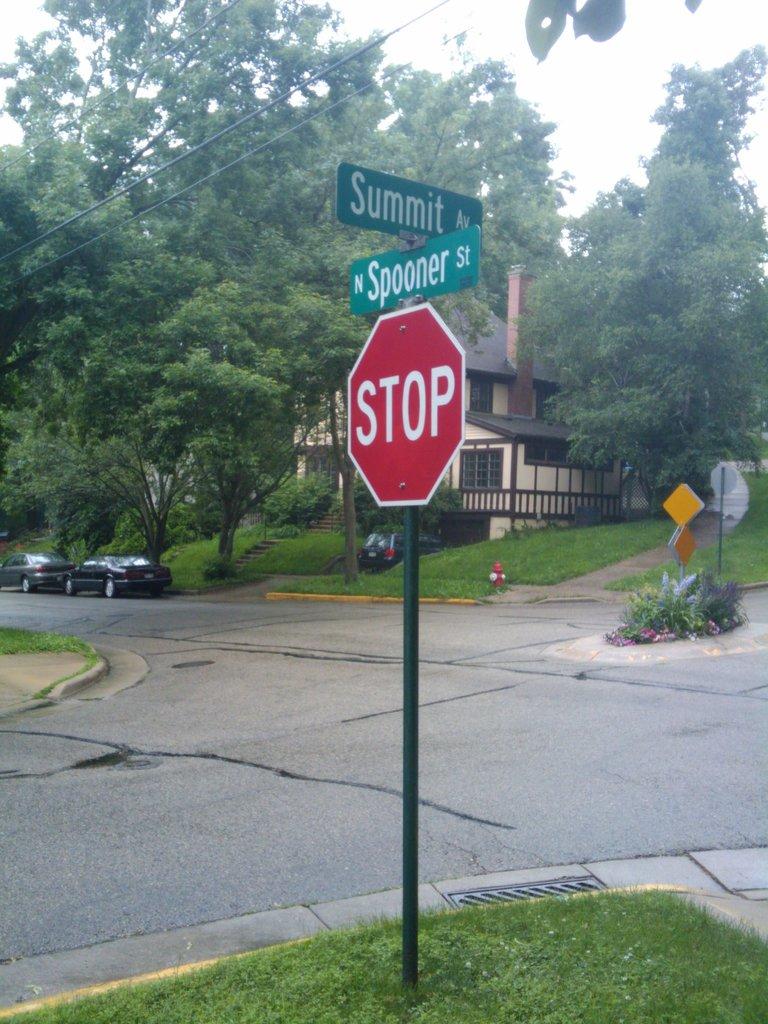What intersection is this?
Your answer should be very brief. Summit and spooner. What avenue is on the top of the post?
Give a very brief answer. Summit. 